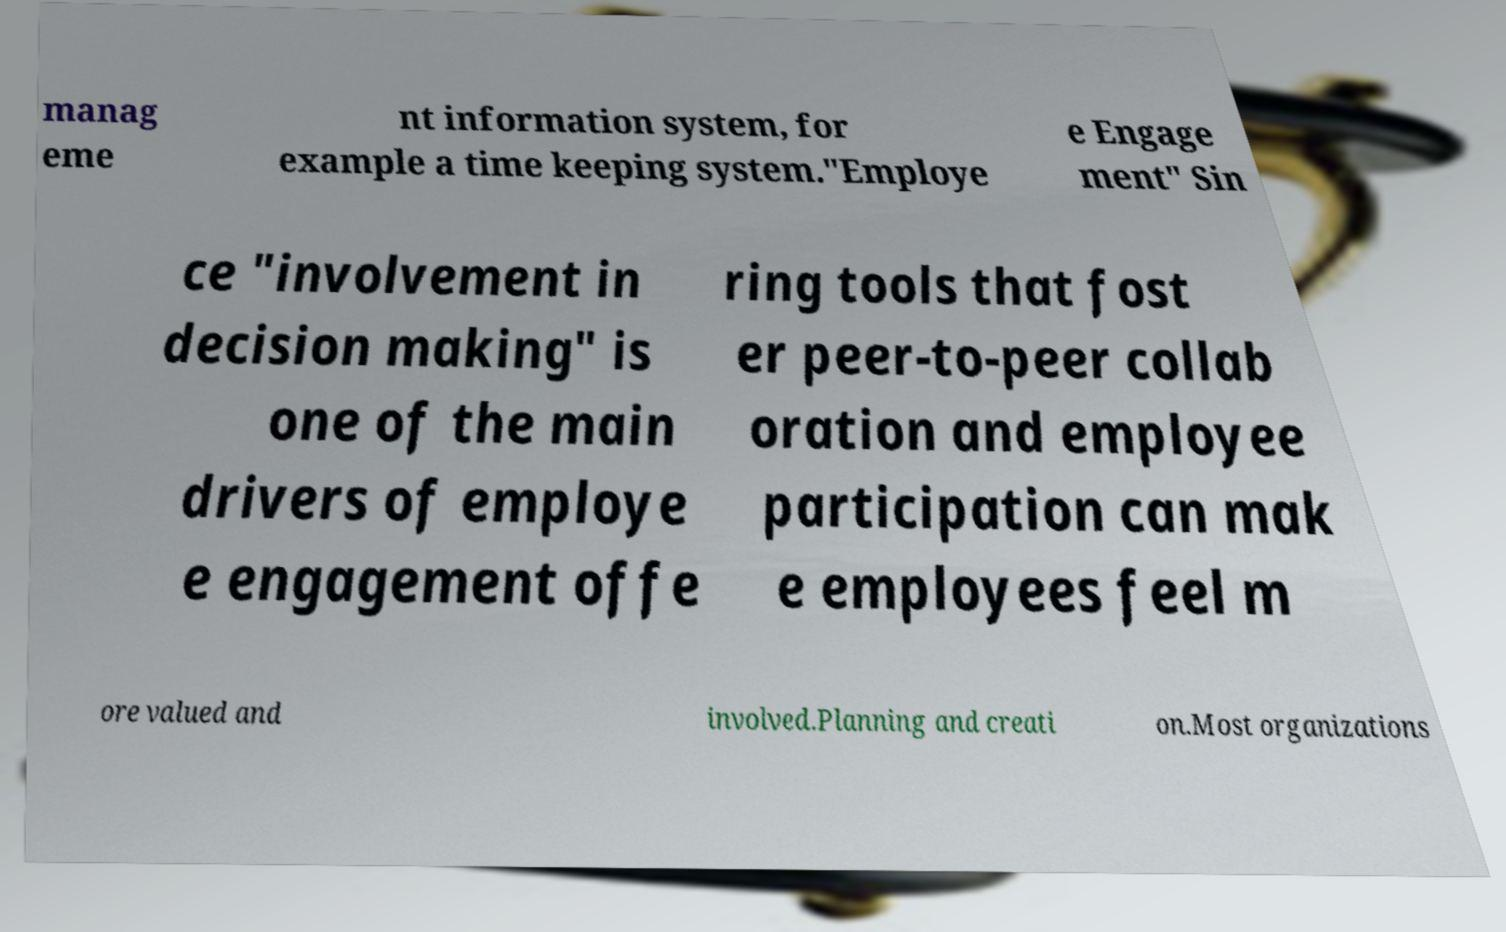What messages or text are displayed in this image? I need them in a readable, typed format. manag eme nt information system, for example a time keeping system."Employe e Engage ment" Sin ce "involvement in decision making" is one of the main drivers of employe e engagement offe ring tools that fost er peer-to-peer collab oration and employee participation can mak e employees feel m ore valued and involved.Planning and creati on.Most organizations 